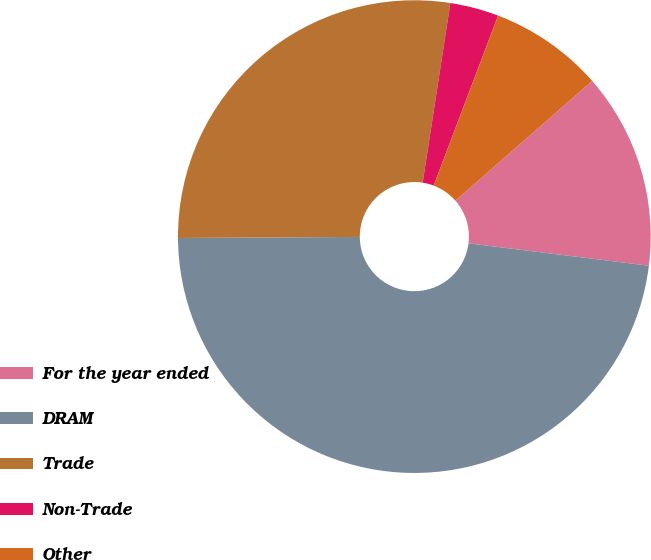Convert chart to OTSL. <chart><loc_0><loc_0><loc_500><loc_500><pie_chart><fcel>For the year ended<fcel>DRAM<fcel>Trade<fcel>Non-Trade<fcel>Other<nl><fcel>13.41%<fcel>47.94%<fcel>27.53%<fcel>3.33%<fcel>7.79%<nl></chart> 